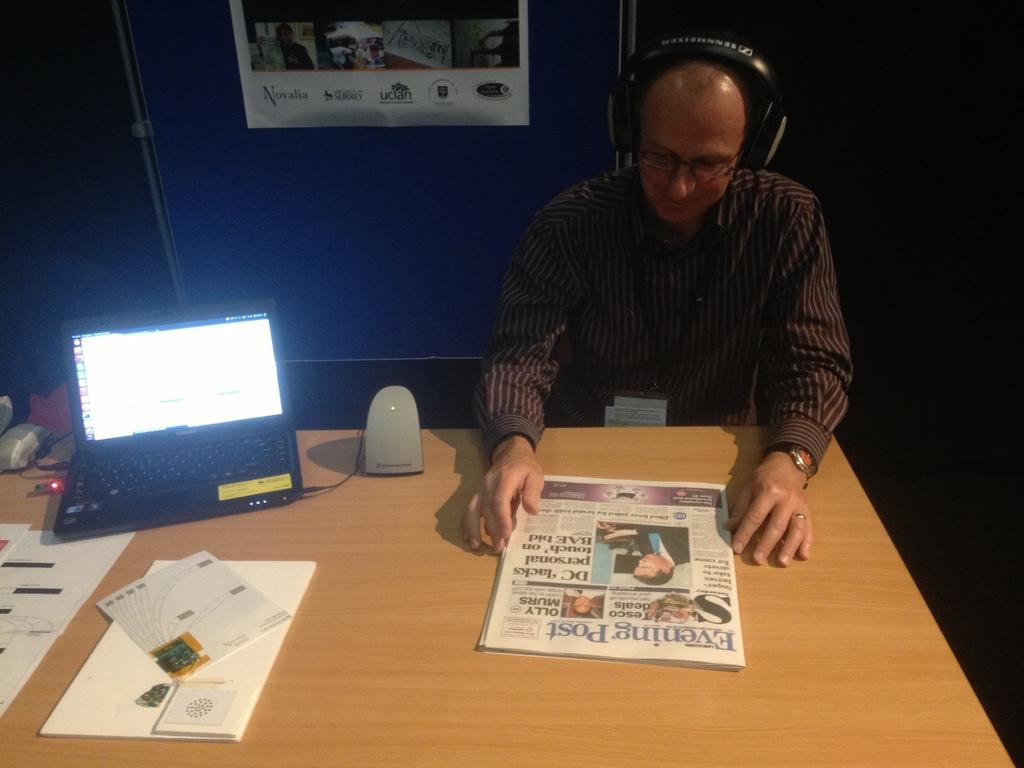<image>
Offer a succinct explanation of the picture presented. a man reading a newspaper that is titled 'evening post' 